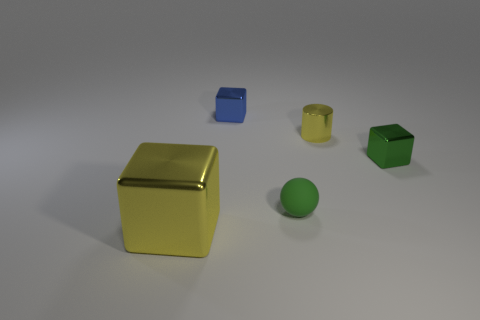Are there the same number of cylinders in front of the sphere and blocks?
Your response must be concise. No. Is there any other thing that has the same size as the blue metal object?
Keep it short and to the point. Yes. What is the color of the other tiny metal thing that is the same shape as the blue thing?
Offer a very short reply. Green. What number of other metallic things are the same shape as the big yellow thing?
Your answer should be compact. 2. What number of metallic objects are there?
Ensure brevity in your answer.  4. Is there a large yellow cube that has the same material as the tiny blue cube?
Offer a very short reply. Yes. The cube that is the same color as the matte sphere is what size?
Keep it short and to the point. Small. There is a metal cube that is on the right side of the tiny blue cube; is its size the same as the yellow metallic thing that is on the left side of the small blue metallic block?
Your answer should be compact. No. What size is the thing left of the blue shiny thing?
Your answer should be compact. Large. Are there any cylinders that have the same color as the big metallic object?
Provide a succinct answer. Yes. 